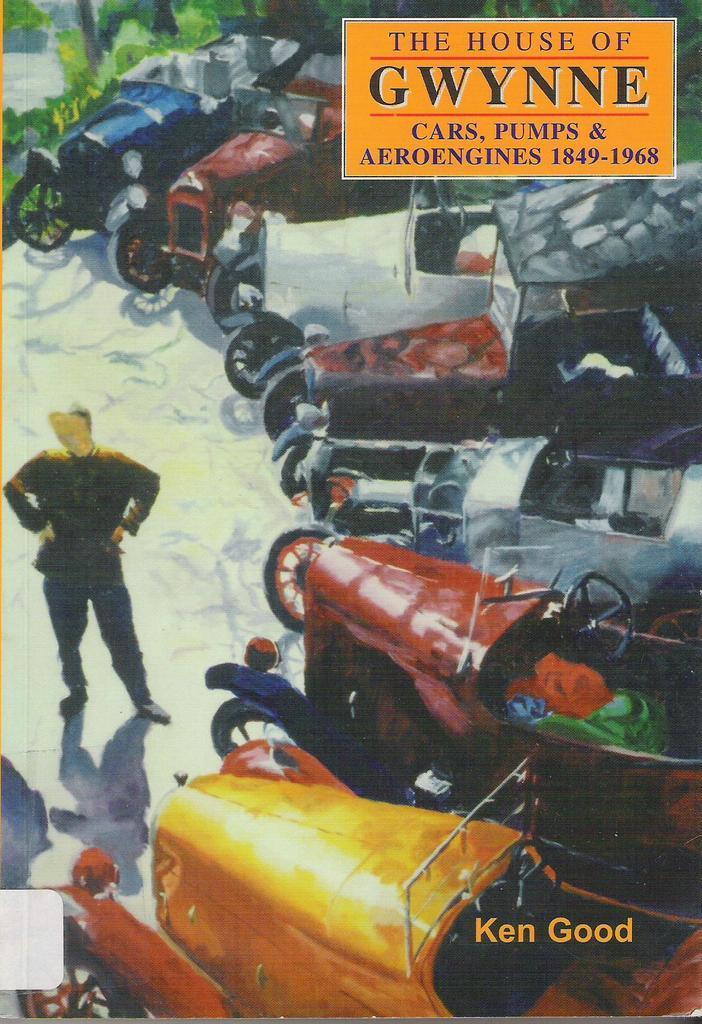Please provide a concise description of this image. In the picture we can see a poster with a painting of some vintage cars and in front of it we can see a man standing keeping hands on his hip and on the poster we can see a label with a name the house of GWYNNE cars, pumps and Aero engines. 